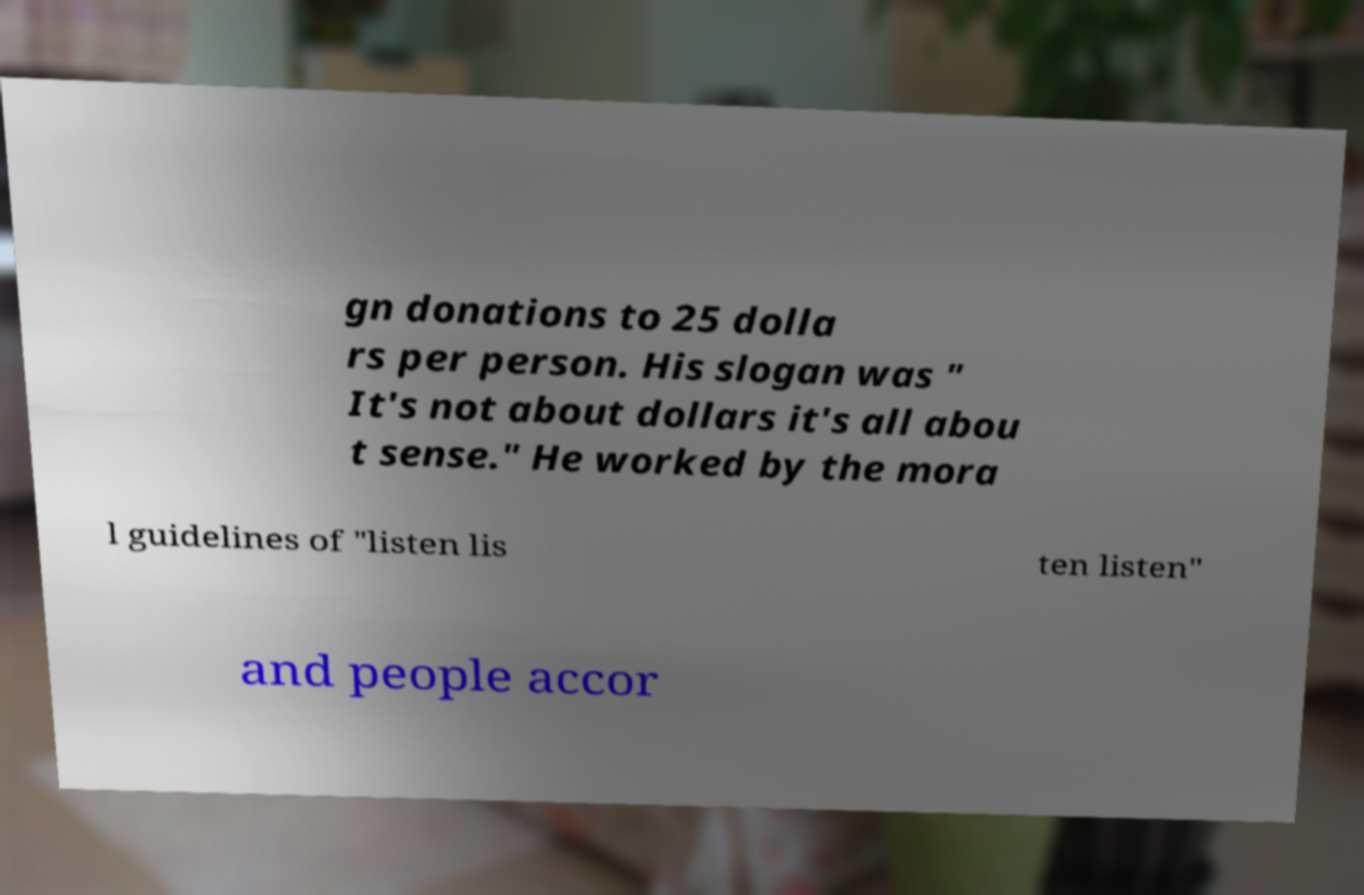Can you read and provide the text displayed in the image?This photo seems to have some interesting text. Can you extract and type it out for me? gn donations to 25 dolla rs per person. His slogan was " It's not about dollars it's all abou t sense." He worked by the mora l guidelines of "listen lis ten listen" and people accor 